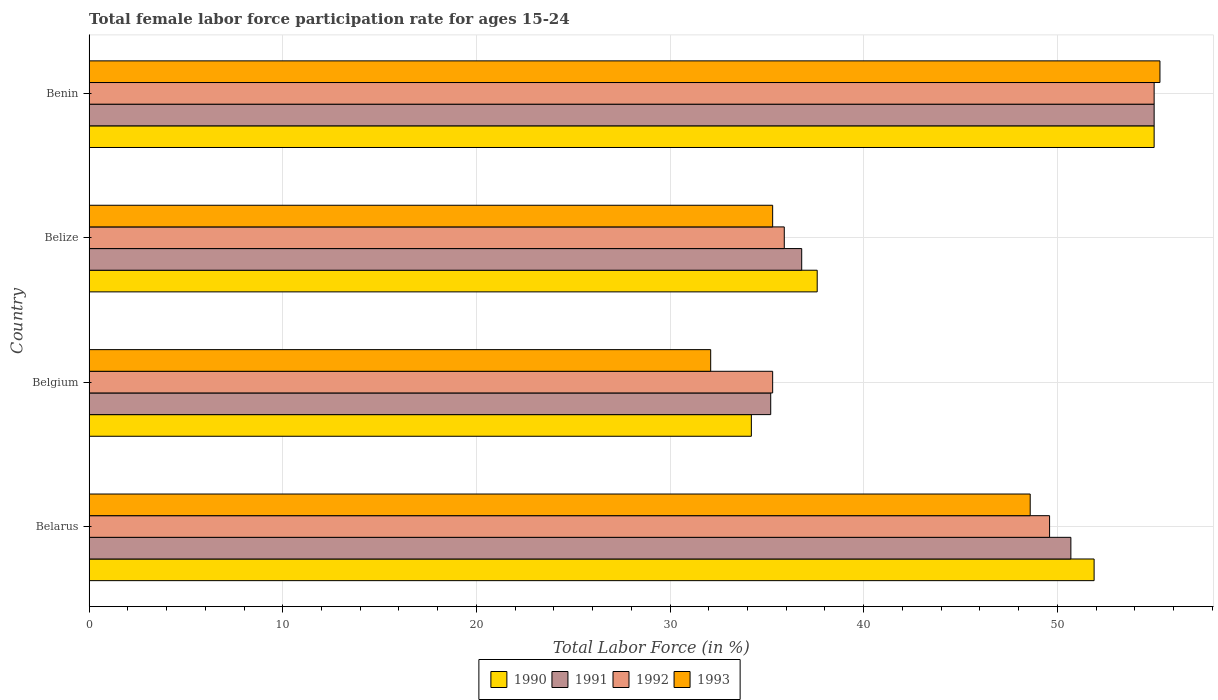How many different coloured bars are there?
Keep it short and to the point. 4. How many groups of bars are there?
Your answer should be compact. 4. What is the label of the 1st group of bars from the top?
Your response must be concise. Benin. In how many cases, is the number of bars for a given country not equal to the number of legend labels?
Provide a short and direct response. 0. What is the female labor force participation rate in 1992 in Belgium?
Offer a terse response. 35.3. Across all countries, what is the minimum female labor force participation rate in 1991?
Offer a very short reply. 35.2. In which country was the female labor force participation rate in 1992 maximum?
Provide a succinct answer. Benin. In which country was the female labor force participation rate in 1992 minimum?
Provide a succinct answer. Belgium. What is the total female labor force participation rate in 1990 in the graph?
Offer a very short reply. 178.7. What is the difference between the female labor force participation rate in 1993 in Belgium and that in Benin?
Provide a succinct answer. -23.2. What is the average female labor force participation rate in 1990 per country?
Offer a very short reply. 44.68. What is the difference between the female labor force participation rate in 1991 and female labor force participation rate in 1992 in Benin?
Your response must be concise. 0. In how many countries, is the female labor force participation rate in 1992 greater than 32 %?
Your answer should be compact. 4. What is the ratio of the female labor force participation rate in 1990 in Belgium to that in Benin?
Keep it short and to the point. 0.62. Is the female labor force participation rate in 1990 in Belarus less than that in Benin?
Your answer should be compact. Yes. Is the difference between the female labor force participation rate in 1991 in Belgium and Benin greater than the difference between the female labor force participation rate in 1992 in Belgium and Benin?
Make the answer very short. No. What is the difference between the highest and the second highest female labor force participation rate in 1992?
Your answer should be compact. 5.4. What is the difference between the highest and the lowest female labor force participation rate in 1991?
Make the answer very short. 19.8. In how many countries, is the female labor force participation rate in 1990 greater than the average female labor force participation rate in 1990 taken over all countries?
Your answer should be very brief. 2. Is the sum of the female labor force participation rate in 1990 in Belize and Benin greater than the maximum female labor force participation rate in 1991 across all countries?
Make the answer very short. Yes. Is it the case that in every country, the sum of the female labor force participation rate in 1992 and female labor force participation rate in 1991 is greater than the female labor force participation rate in 1990?
Keep it short and to the point. Yes. Are all the bars in the graph horizontal?
Your response must be concise. Yes. How many countries are there in the graph?
Keep it short and to the point. 4. What is the difference between two consecutive major ticks on the X-axis?
Provide a short and direct response. 10. Does the graph contain grids?
Give a very brief answer. Yes. How many legend labels are there?
Give a very brief answer. 4. What is the title of the graph?
Your response must be concise. Total female labor force participation rate for ages 15-24. Does "1987" appear as one of the legend labels in the graph?
Give a very brief answer. No. What is the label or title of the X-axis?
Make the answer very short. Total Labor Force (in %). What is the Total Labor Force (in %) in 1990 in Belarus?
Keep it short and to the point. 51.9. What is the Total Labor Force (in %) of 1991 in Belarus?
Give a very brief answer. 50.7. What is the Total Labor Force (in %) of 1992 in Belarus?
Keep it short and to the point. 49.6. What is the Total Labor Force (in %) in 1993 in Belarus?
Give a very brief answer. 48.6. What is the Total Labor Force (in %) of 1990 in Belgium?
Your answer should be compact. 34.2. What is the Total Labor Force (in %) in 1991 in Belgium?
Provide a short and direct response. 35.2. What is the Total Labor Force (in %) in 1992 in Belgium?
Provide a short and direct response. 35.3. What is the Total Labor Force (in %) of 1993 in Belgium?
Your answer should be very brief. 32.1. What is the Total Labor Force (in %) of 1990 in Belize?
Your answer should be compact. 37.6. What is the Total Labor Force (in %) of 1991 in Belize?
Your answer should be very brief. 36.8. What is the Total Labor Force (in %) of 1992 in Belize?
Keep it short and to the point. 35.9. What is the Total Labor Force (in %) of 1993 in Belize?
Your answer should be very brief. 35.3. What is the Total Labor Force (in %) of 1991 in Benin?
Your answer should be compact. 55. What is the Total Labor Force (in %) of 1993 in Benin?
Your answer should be compact. 55.3. Across all countries, what is the maximum Total Labor Force (in %) in 1990?
Give a very brief answer. 55. Across all countries, what is the maximum Total Labor Force (in %) in 1992?
Offer a terse response. 55. Across all countries, what is the maximum Total Labor Force (in %) of 1993?
Make the answer very short. 55.3. Across all countries, what is the minimum Total Labor Force (in %) in 1990?
Provide a succinct answer. 34.2. Across all countries, what is the minimum Total Labor Force (in %) of 1991?
Your response must be concise. 35.2. Across all countries, what is the minimum Total Labor Force (in %) of 1992?
Ensure brevity in your answer.  35.3. Across all countries, what is the minimum Total Labor Force (in %) of 1993?
Offer a very short reply. 32.1. What is the total Total Labor Force (in %) of 1990 in the graph?
Make the answer very short. 178.7. What is the total Total Labor Force (in %) of 1991 in the graph?
Your answer should be very brief. 177.7. What is the total Total Labor Force (in %) in 1992 in the graph?
Keep it short and to the point. 175.8. What is the total Total Labor Force (in %) in 1993 in the graph?
Ensure brevity in your answer.  171.3. What is the difference between the Total Labor Force (in %) of 1990 in Belarus and that in Belgium?
Your response must be concise. 17.7. What is the difference between the Total Labor Force (in %) in 1991 in Belarus and that in Belgium?
Give a very brief answer. 15.5. What is the difference between the Total Labor Force (in %) in 1993 in Belarus and that in Belgium?
Offer a terse response. 16.5. What is the difference between the Total Labor Force (in %) in 1990 in Belarus and that in Belize?
Offer a terse response. 14.3. What is the difference between the Total Labor Force (in %) of 1992 in Belarus and that in Benin?
Your answer should be very brief. -5.4. What is the difference between the Total Labor Force (in %) in 1992 in Belgium and that in Belize?
Offer a very short reply. -0.6. What is the difference between the Total Labor Force (in %) in 1990 in Belgium and that in Benin?
Offer a very short reply. -20.8. What is the difference between the Total Labor Force (in %) of 1991 in Belgium and that in Benin?
Provide a succinct answer. -19.8. What is the difference between the Total Labor Force (in %) in 1992 in Belgium and that in Benin?
Make the answer very short. -19.7. What is the difference between the Total Labor Force (in %) of 1993 in Belgium and that in Benin?
Offer a very short reply. -23.2. What is the difference between the Total Labor Force (in %) in 1990 in Belize and that in Benin?
Provide a succinct answer. -17.4. What is the difference between the Total Labor Force (in %) in 1991 in Belize and that in Benin?
Provide a short and direct response. -18.2. What is the difference between the Total Labor Force (in %) in 1992 in Belize and that in Benin?
Provide a short and direct response. -19.1. What is the difference between the Total Labor Force (in %) of 1993 in Belize and that in Benin?
Offer a very short reply. -20. What is the difference between the Total Labor Force (in %) in 1990 in Belarus and the Total Labor Force (in %) in 1991 in Belgium?
Your response must be concise. 16.7. What is the difference between the Total Labor Force (in %) in 1990 in Belarus and the Total Labor Force (in %) in 1993 in Belgium?
Your response must be concise. 19.8. What is the difference between the Total Labor Force (in %) in 1990 in Belarus and the Total Labor Force (in %) in 1992 in Belize?
Your answer should be very brief. 16. What is the difference between the Total Labor Force (in %) in 1990 in Belarus and the Total Labor Force (in %) in 1993 in Belize?
Your answer should be compact. 16.6. What is the difference between the Total Labor Force (in %) of 1992 in Belarus and the Total Labor Force (in %) of 1993 in Benin?
Your answer should be very brief. -5.7. What is the difference between the Total Labor Force (in %) in 1992 in Belgium and the Total Labor Force (in %) in 1993 in Belize?
Make the answer very short. 0. What is the difference between the Total Labor Force (in %) in 1990 in Belgium and the Total Labor Force (in %) in 1991 in Benin?
Keep it short and to the point. -20.8. What is the difference between the Total Labor Force (in %) in 1990 in Belgium and the Total Labor Force (in %) in 1992 in Benin?
Make the answer very short. -20.8. What is the difference between the Total Labor Force (in %) in 1990 in Belgium and the Total Labor Force (in %) in 1993 in Benin?
Your response must be concise. -21.1. What is the difference between the Total Labor Force (in %) in 1991 in Belgium and the Total Labor Force (in %) in 1992 in Benin?
Provide a short and direct response. -19.8. What is the difference between the Total Labor Force (in %) in 1991 in Belgium and the Total Labor Force (in %) in 1993 in Benin?
Provide a succinct answer. -20.1. What is the difference between the Total Labor Force (in %) in 1992 in Belgium and the Total Labor Force (in %) in 1993 in Benin?
Offer a terse response. -20. What is the difference between the Total Labor Force (in %) in 1990 in Belize and the Total Labor Force (in %) in 1991 in Benin?
Provide a succinct answer. -17.4. What is the difference between the Total Labor Force (in %) in 1990 in Belize and the Total Labor Force (in %) in 1992 in Benin?
Offer a terse response. -17.4. What is the difference between the Total Labor Force (in %) in 1990 in Belize and the Total Labor Force (in %) in 1993 in Benin?
Give a very brief answer. -17.7. What is the difference between the Total Labor Force (in %) in 1991 in Belize and the Total Labor Force (in %) in 1992 in Benin?
Your response must be concise. -18.2. What is the difference between the Total Labor Force (in %) in 1991 in Belize and the Total Labor Force (in %) in 1993 in Benin?
Ensure brevity in your answer.  -18.5. What is the difference between the Total Labor Force (in %) in 1992 in Belize and the Total Labor Force (in %) in 1993 in Benin?
Your response must be concise. -19.4. What is the average Total Labor Force (in %) in 1990 per country?
Offer a terse response. 44.67. What is the average Total Labor Force (in %) of 1991 per country?
Your answer should be very brief. 44.42. What is the average Total Labor Force (in %) of 1992 per country?
Keep it short and to the point. 43.95. What is the average Total Labor Force (in %) in 1993 per country?
Your response must be concise. 42.83. What is the difference between the Total Labor Force (in %) in 1990 and Total Labor Force (in %) in 1991 in Belarus?
Keep it short and to the point. 1.2. What is the difference between the Total Labor Force (in %) in 1991 and Total Labor Force (in %) in 1992 in Belarus?
Keep it short and to the point. 1.1. What is the difference between the Total Labor Force (in %) of 1992 and Total Labor Force (in %) of 1993 in Belarus?
Provide a succinct answer. 1. What is the difference between the Total Labor Force (in %) of 1990 and Total Labor Force (in %) of 1991 in Belgium?
Keep it short and to the point. -1. What is the difference between the Total Labor Force (in %) of 1990 and Total Labor Force (in %) of 1992 in Belgium?
Ensure brevity in your answer.  -1.1. What is the difference between the Total Labor Force (in %) in 1991 and Total Labor Force (in %) in 1992 in Belgium?
Ensure brevity in your answer.  -0.1. What is the difference between the Total Labor Force (in %) of 1991 and Total Labor Force (in %) of 1993 in Belgium?
Make the answer very short. 3.1. What is the difference between the Total Labor Force (in %) in 1992 and Total Labor Force (in %) in 1993 in Belgium?
Offer a very short reply. 3.2. What is the difference between the Total Labor Force (in %) in 1990 and Total Labor Force (in %) in 1991 in Belize?
Give a very brief answer. 0.8. What is the difference between the Total Labor Force (in %) in 1990 and Total Labor Force (in %) in 1992 in Belize?
Keep it short and to the point. 1.7. What is the difference between the Total Labor Force (in %) in 1990 and Total Labor Force (in %) in 1993 in Belize?
Ensure brevity in your answer.  2.3. What is the difference between the Total Labor Force (in %) in 1991 and Total Labor Force (in %) in 1992 in Belize?
Ensure brevity in your answer.  0.9. What is the difference between the Total Labor Force (in %) in 1990 and Total Labor Force (in %) in 1991 in Benin?
Make the answer very short. 0. What is the difference between the Total Labor Force (in %) in 1992 and Total Labor Force (in %) in 1993 in Benin?
Offer a terse response. -0.3. What is the ratio of the Total Labor Force (in %) in 1990 in Belarus to that in Belgium?
Offer a very short reply. 1.52. What is the ratio of the Total Labor Force (in %) of 1991 in Belarus to that in Belgium?
Offer a very short reply. 1.44. What is the ratio of the Total Labor Force (in %) of 1992 in Belarus to that in Belgium?
Make the answer very short. 1.41. What is the ratio of the Total Labor Force (in %) of 1993 in Belarus to that in Belgium?
Offer a very short reply. 1.51. What is the ratio of the Total Labor Force (in %) in 1990 in Belarus to that in Belize?
Offer a terse response. 1.38. What is the ratio of the Total Labor Force (in %) in 1991 in Belarus to that in Belize?
Offer a terse response. 1.38. What is the ratio of the Total Labor Force (in %) in 1992 in Belarus to that in Belize?
Ensure brevity in your answer.  1.38. What is the ratio of the Total Labor Force (in %) of 1993 in Belarus to that in Belize?
Make the answer very short. 1.38. What is the ratio of the Total Labor Force (in %) of 1990 in Belarus to that in Benin?
Your answer should be very brief. 0.94. What is the ratio of the Total Labor Force (in %) in 1991 in Belarus to that in Benin?
Offer a terse response. 0.92. What is the ratio of the Total Labor Force (in %) in 1992 in Belarus to that in Benin?
Provide a succinct answer. 0.9. What is the ratio of the Total Labor Force (in %) of 1993 in Belarus to that in Benin?
Make the answer very short. 0.88. What is the ratio of the Total Labor Force (in %) of 1990 in Belgium to that in Belize?
Keep it short and to the point. 0.91. What is the ratio of the Total Labor Force (in %) in 1991 in Belgium to that in Belize?
Offer a terse response. 0.96. What is the ratio of the Total Labor Force (in %) in 1992 in Belgium to that in Belize?
Provide a short and direct response. 0.98. What is the ratio of the Total Labor Force (in %) of 1993 in Belgium to that in Belize?
Offer a terse response. 0.91. What is the ratio of the Total Labor Force (in %) in 1990 in Belgium to that in Benin?
Give a very brief answer. 0.62. What is the ratio of the Total Labor Force (in %) in 1991 in Belgium to that in Benin?
Give a very brief answer. 0.64. What is the ratio of the Total Labor Force (in %) in 1992 in Belgium to that in Benin?
Offer a very short reply. 0.64. What is the ratio of the Total Labor Force (in %) of 1993 in Belgium to that in Benin?
Give a very brief answer. 0.58. What is the ratio of the Total Labor Force (in %) in 1990 in Belize to that in Benin?
Keep it short and to the point. 0.68. What is the ratio of the Total Labor Force (in %) of 1991 in Belize to that in Benin?
Provide a short and direct response. 0.67. What is the ratio of the Total Labor Force (in %) in 1992 in Belize to that in Benin?
Ensure brevity in your answer.  0.65. What is the ratio of the Total Labor Force (in %) in 1993 in Belize to that in Benin?
Your answer should be very brief. 0.64. What is the difference between the highest and the second highest Total Labor Force (in %) of 1990?
Ensure brevity in your answer.  3.1. What is the difference between the highest and the lowest Total Labor Force (in %) in 1990?
Ensure brevity in your answer.  20.8. What is the difference between the highest and the lowest Total Labor Force (in %) of 1991?
Your response must be concise. 19.8. What is the difference between the highest and the lowest Total Labor Force (in %) in 1992?
Ensure brevity in your answer.  19.7. What is the difference between the highest and the lowest Total Labor Force (in %) of 1993?
Your response must be concise. 23.2. 